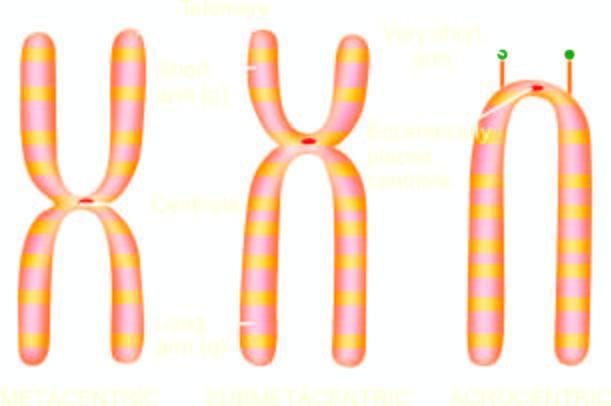s the serial numbers in the figure base on size and location of centromere?
Answer the question using a single word or phrase. No 